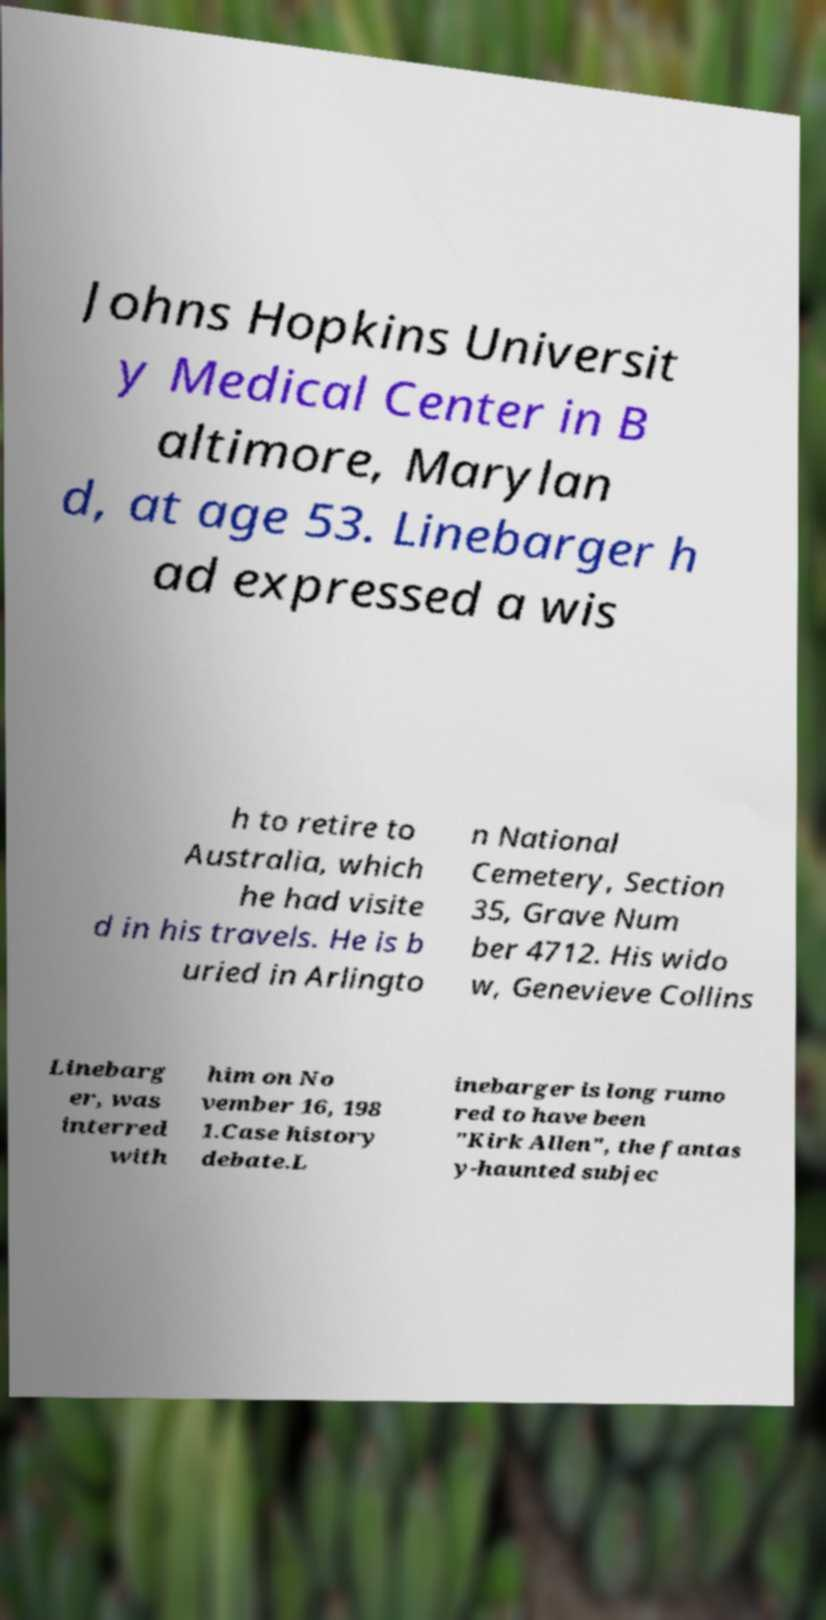Can you read and provide the text displayed in the image?This photo seems to have some interesting text. Can you extract and type it out for me? Johns Hopkins Universit y Medical Center in B altimore, Marylan d, at age 53. Linebarger h ad expressed a wis h to retire to Australia, which he had visite d in his travels. He is b uried in Arlingto n National Cemetery, Section 35, Grave Num ber 4712. His wido w, Genevieve Collins Linebarg er, was interred with him on No vember 16, 198 1.Case history debate.L inebarger is long rumo red to have been "Kirk Allen", the fantas y-haunted subjec 